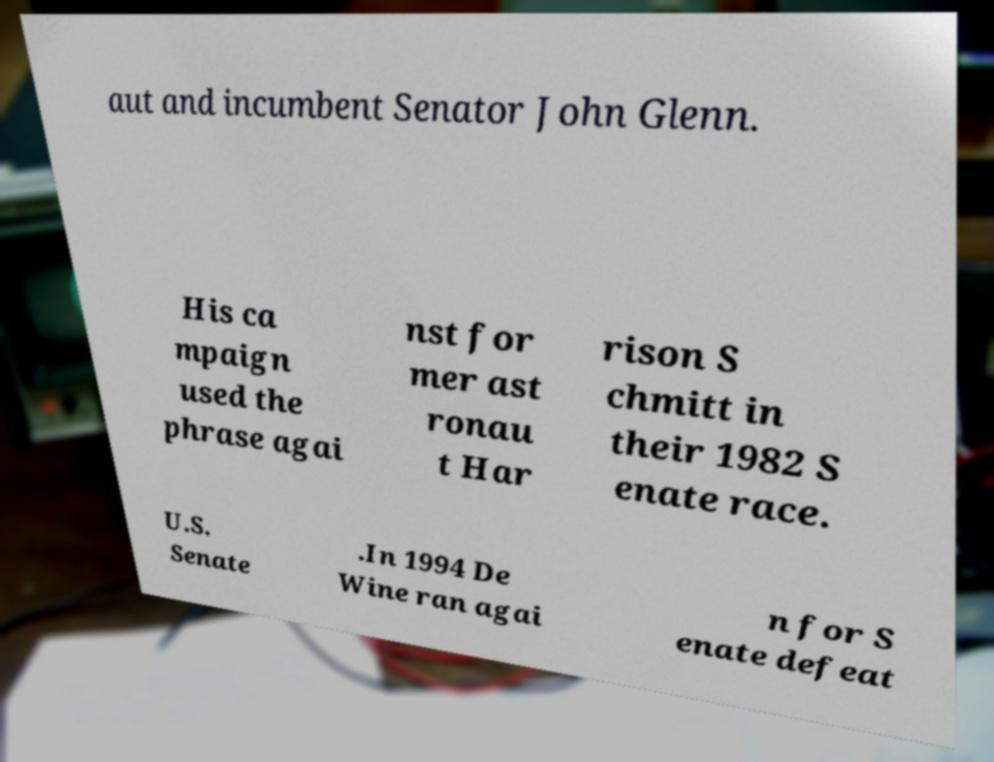Can you read and provide the text displayed in the image?This photo seems to have some interesting text. Can you extract and type it out for me? aut and incumbent Senator John Glenn. His ca mpaign used the phrase agai nst for mer ast ronau t Har rison S chmitt in their 1982 S enate race. U.S. Senate .In 1994 De Wine ran agai n for S enate defeat 